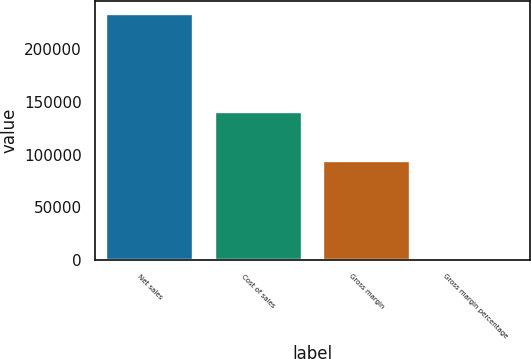<chart> <loc_0><loc_0><loc_500><loc_500><bar_chart><fcel>Net sales<fcel>Cost of sales<fcel>Gross margin<fcel>Gross margin percentage<nl><fcel>233715<fcel>140089<fcel>93626<fcel>40.1<nl></chart> 